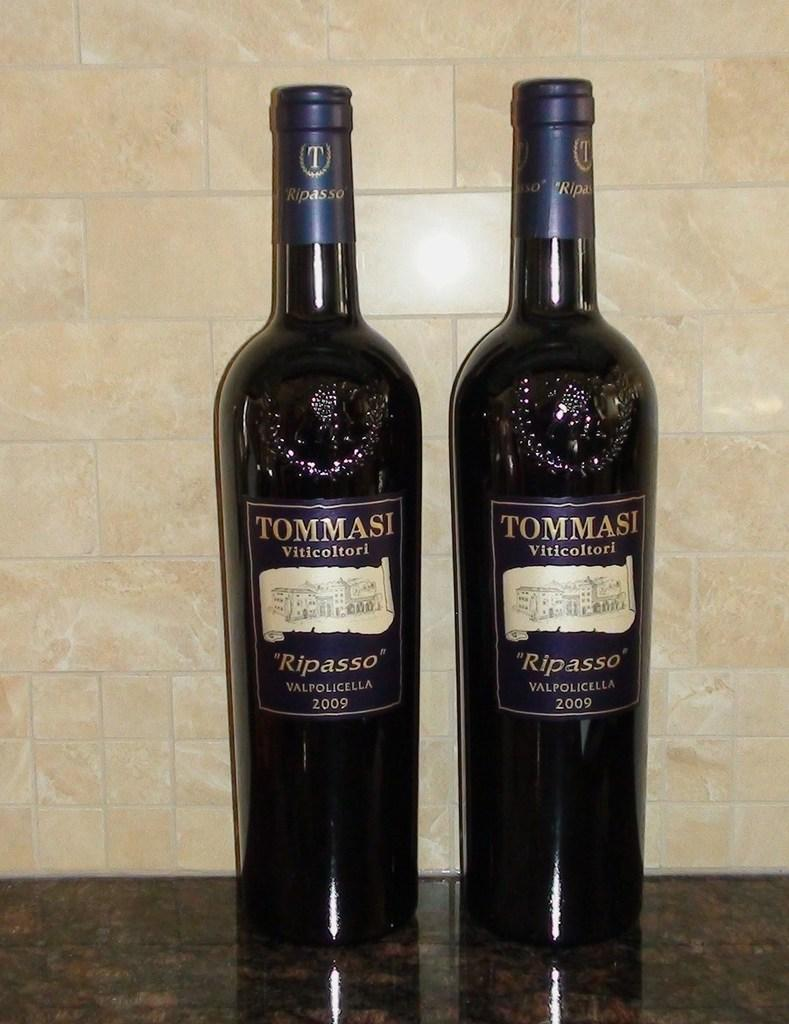<image>
Present a compact description of the photo's key features. two purple bottles of Tommasi Viticoltori wine from 2009 